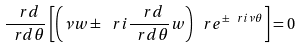<formula> <loc_0><loc_0><loc_500><loc_500>\frac { \ r d } { \ r d \theta } \left [ \left ( \nu w \pm \ r i \frac { \ r d } { \ r d \theta } w \right ) \ r e ^ { \pm \ r i \nu \theta } \right ] = 0</formula> 